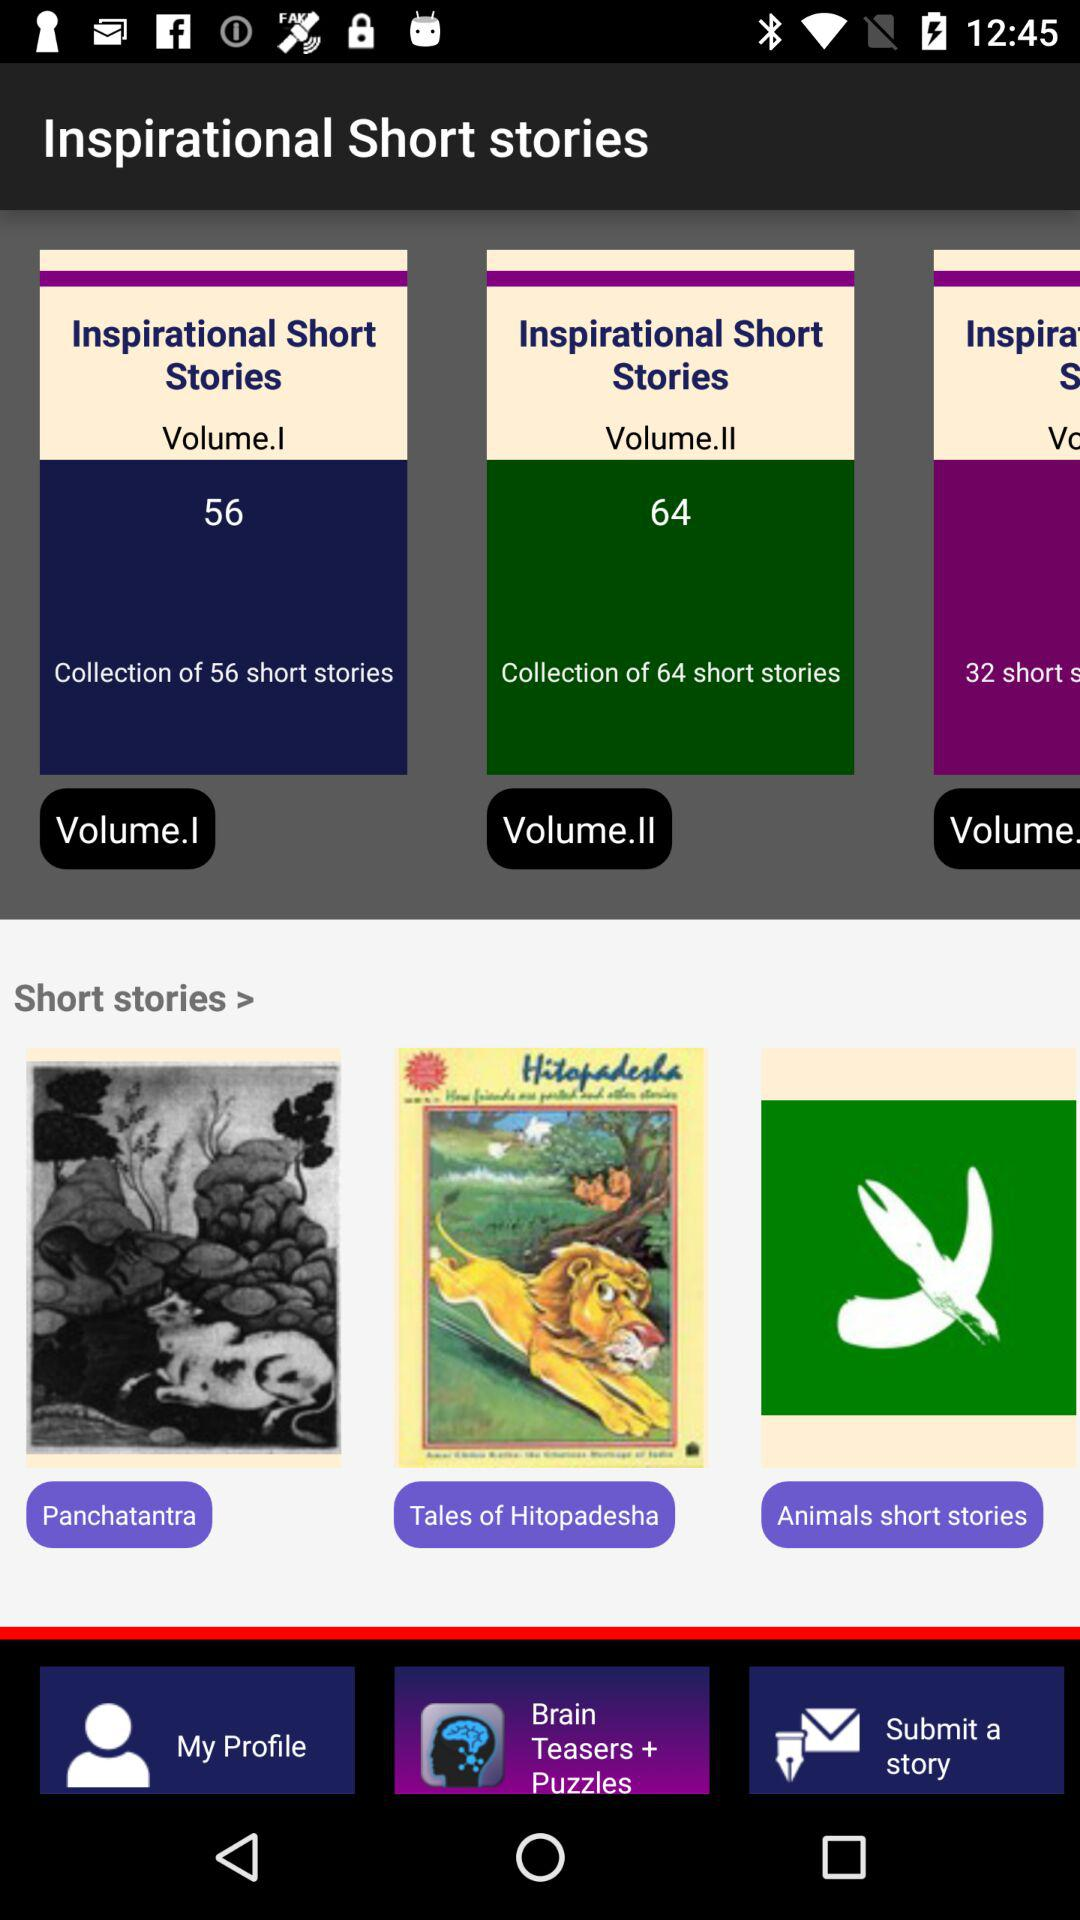How many stories are there in Inspirational Short Stories Volume I? There are 56 stories. 